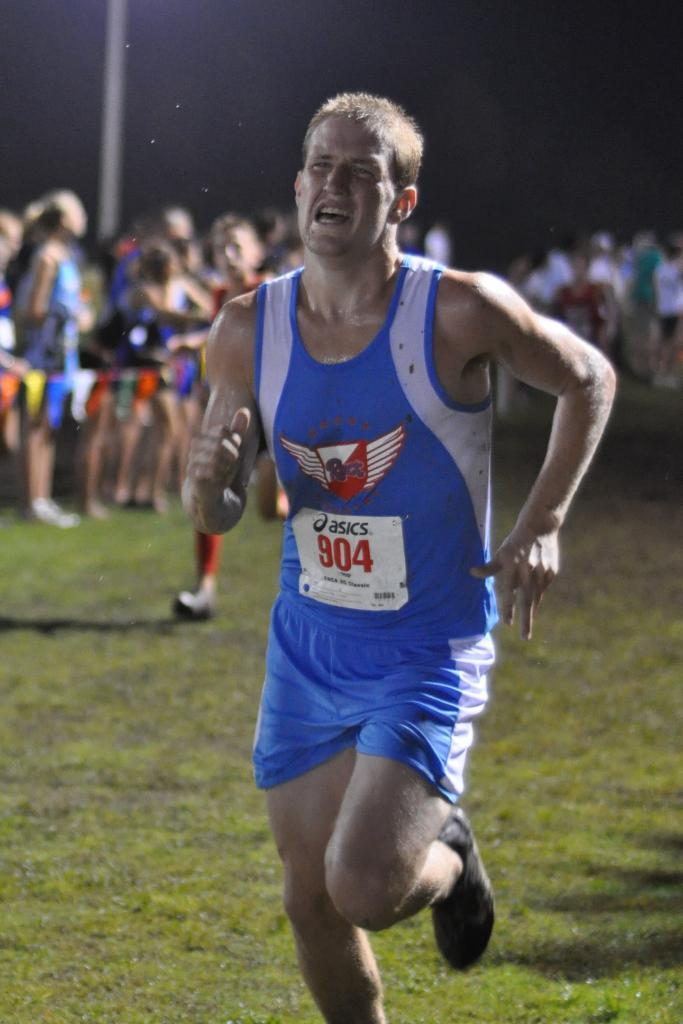<image>
Create a compact narrative representing the image presented. Basics runner number 904 in race with people on the sidelines 